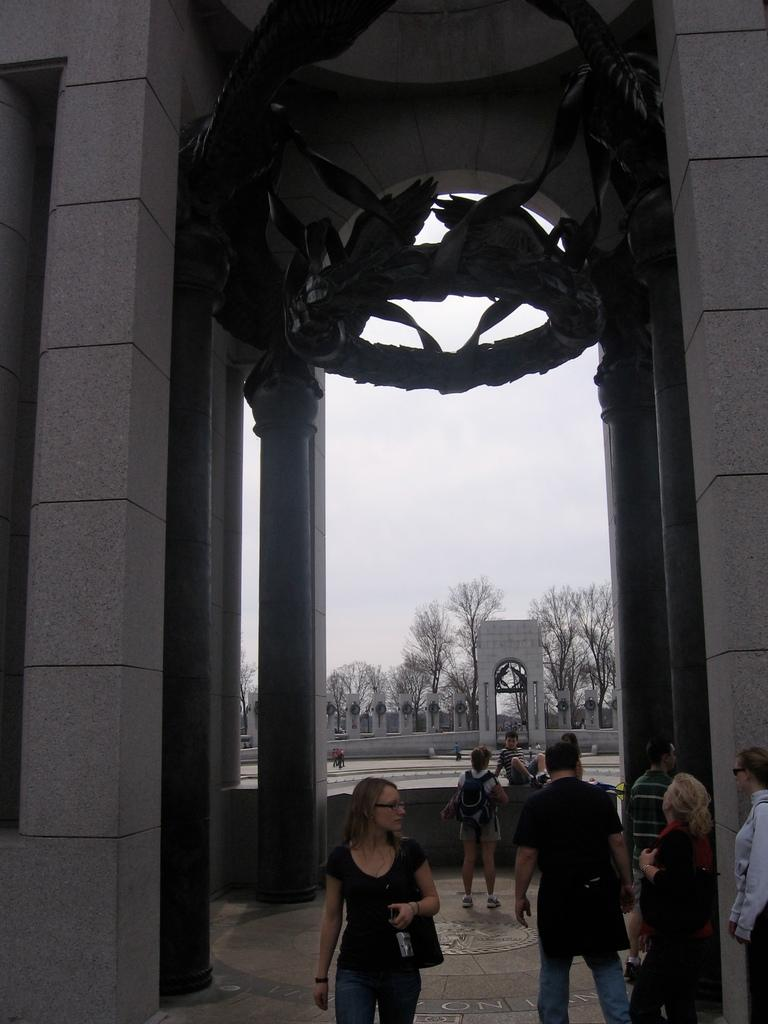How many people are in the image? There is a group of people in the image. What is the position of the people in the image? The people are standing on the ground. What architectural features can be seen in the image? There are pillars in the image. What type of vegetation is present in the image? There are trees in the image. What can be seen in the background of the image? The sky is visible in the background of the image, and clouds are present in the sky. What time is the battle taking place in the image? There is no battle present in the image; it features a group of people standing on the ground with pillars, trees, and a sky with clouds. 